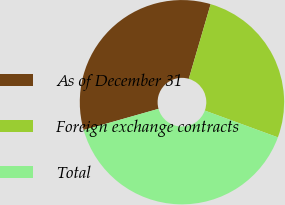Convert chart. <chart><loc_0><loc_0><loc_500><loc_500><pie_chart><fcel>As of December 31<fcel>Foreign exchange contracts<fcel>Total<nl><fcel>33.93%<fcel>26.06%<fcel>40.01%<nl></chart> 